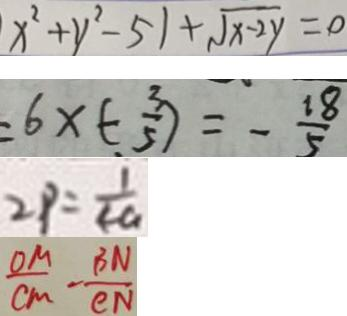<formula> <loc_0><loc_0><loc_500><loc_500>x ^ { 2 } + y ^ { 2 } - 5 1 + \sqrt { x - 2 y } = 0 
 = 6 \times ( - \frac { 3 } { 5 } ) = - \frac { 1 8 } { 5 } 
 2 P = \frac { 1 } { 4 a } 
 \frac { O M } { C M } - \frac { B N } { C N }</formula> 